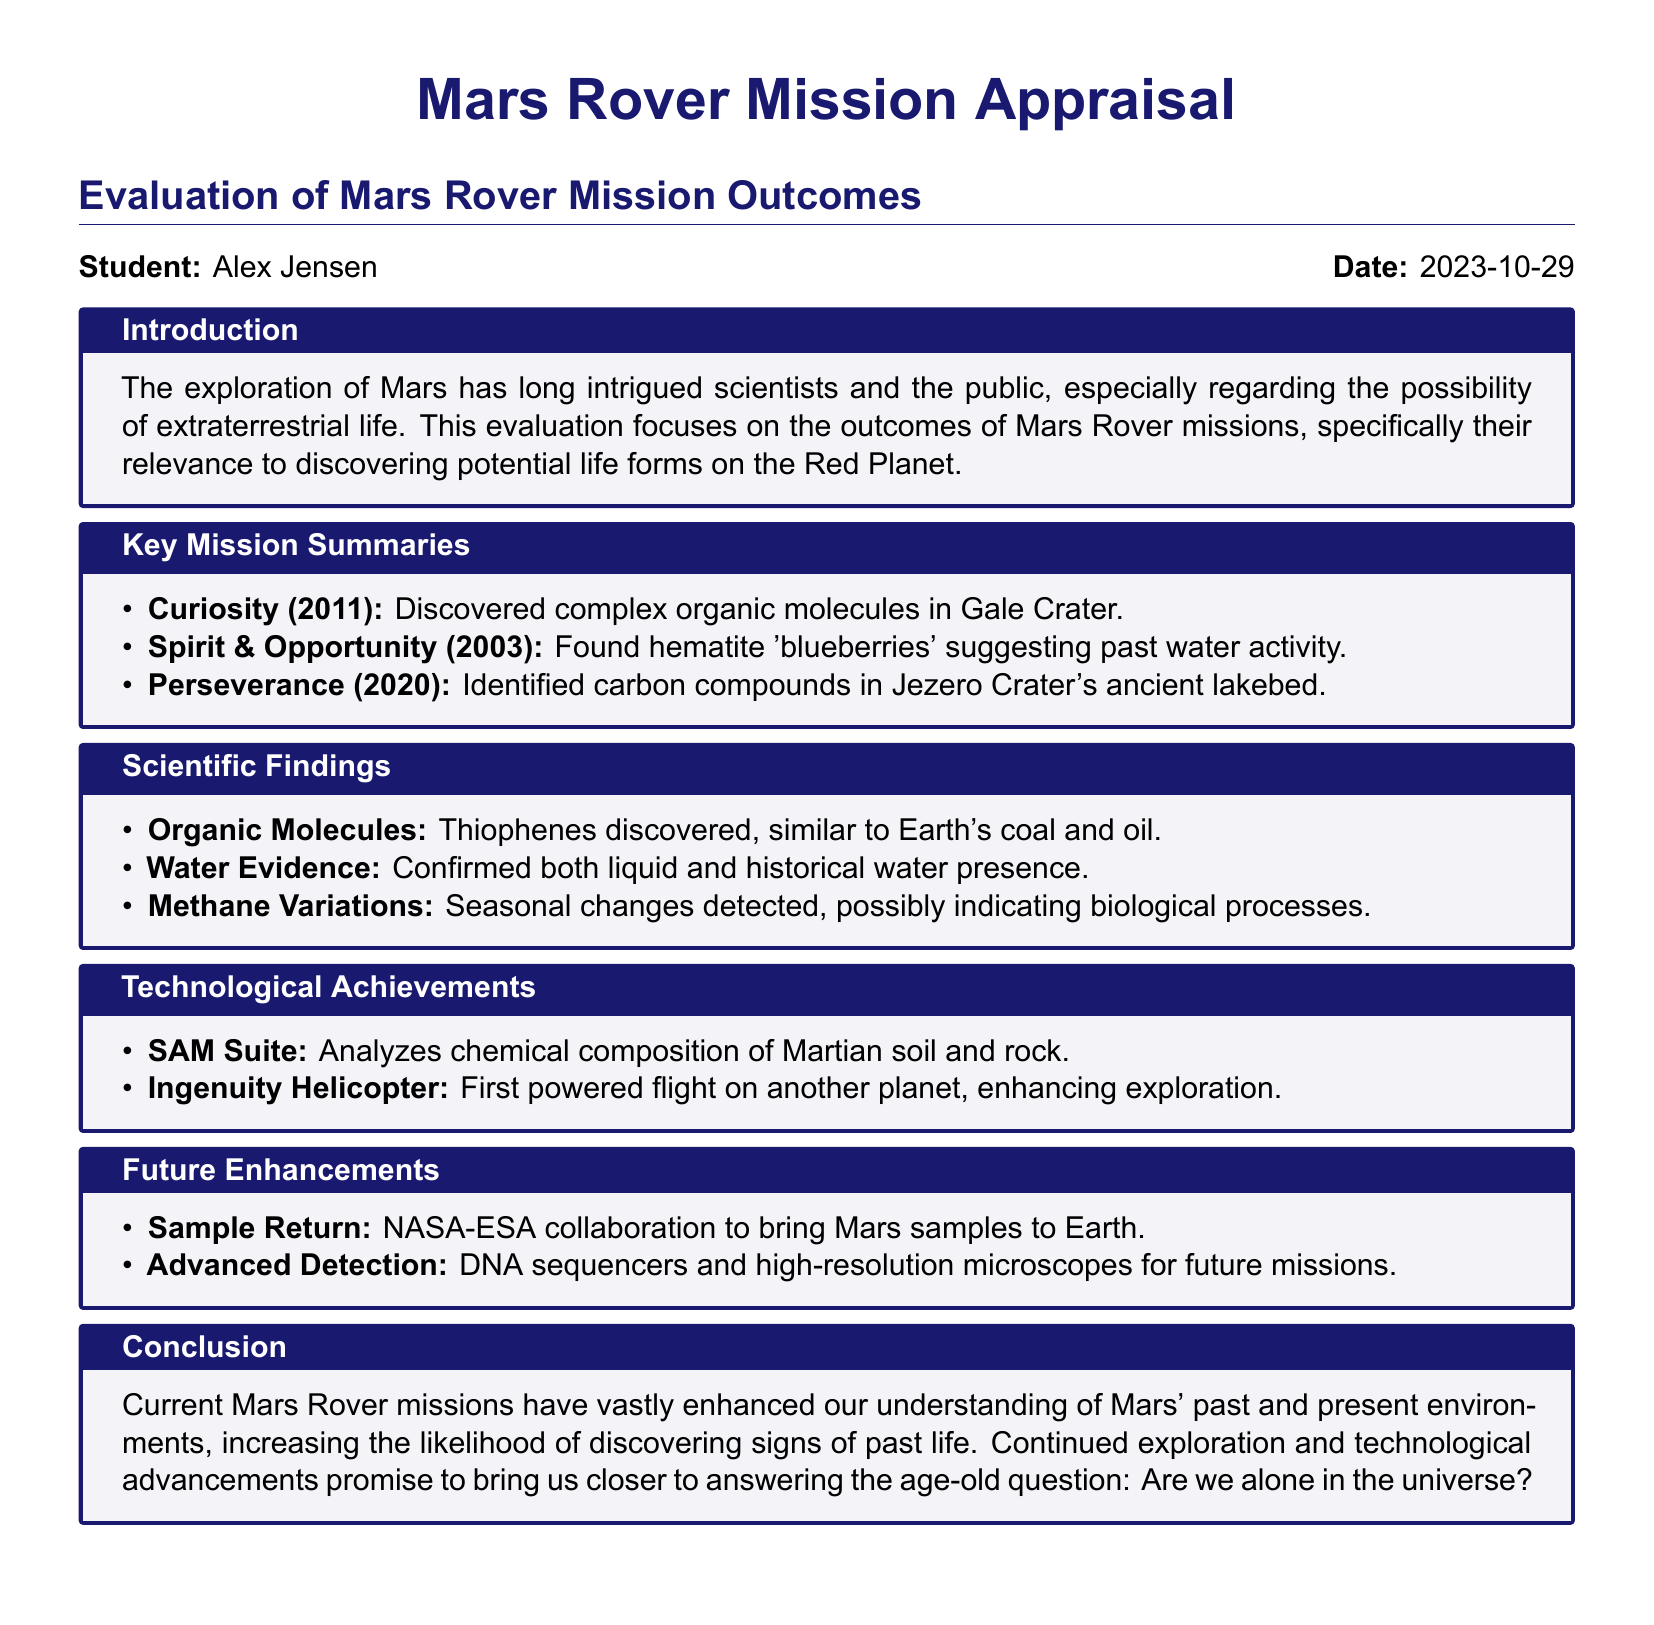What was discovered by Curiosity in Gale Crater? The document states that Curiosity discovered complex organic molecules in Gale Crater.
Answer: complex organic molecules What year was Perseverance launched? According to the document, Perseverance was launched in 2020.
Answer: 2020 What are hematite 'blueberries' indicative of? The document mentions that hematite 'blueberries' suggest past water activity.
Answer: past water activity Which technological achievement enabled the first powered flight on another planet? The document notes that the Ingenuity Helicopter facilitated the first powered flight on another planet.
Answer: Ingenuity Helicopter What collaboration is aimed at bringing Mars samples to Earth? The document refers to a NASA-ESA collaboration focused on sample return to Earth.
Answer: NASA-ESA collaboration How many types of water evidence were confirmed by the missions? The document confirms both liquid and historical water presence, which indicates there are two types.
Answer: two What kind of seasonal changes were detected on Mars? The document describes that methane variations were detected, possibly indicating biological processes.
Answer: methane variations What is the primary focus of the evaluation? The document states that the evaluation focuses on the outcomes of Mars Rover missions relevant to discovering potential life forms.
Answer: outcomes of Mars Rover missions What is one of the future enhancements mentioned? The document lists advanced detection methods, including DNA sequencers, as a future enhancement for upcoming missions.
Answer: advanced detection 